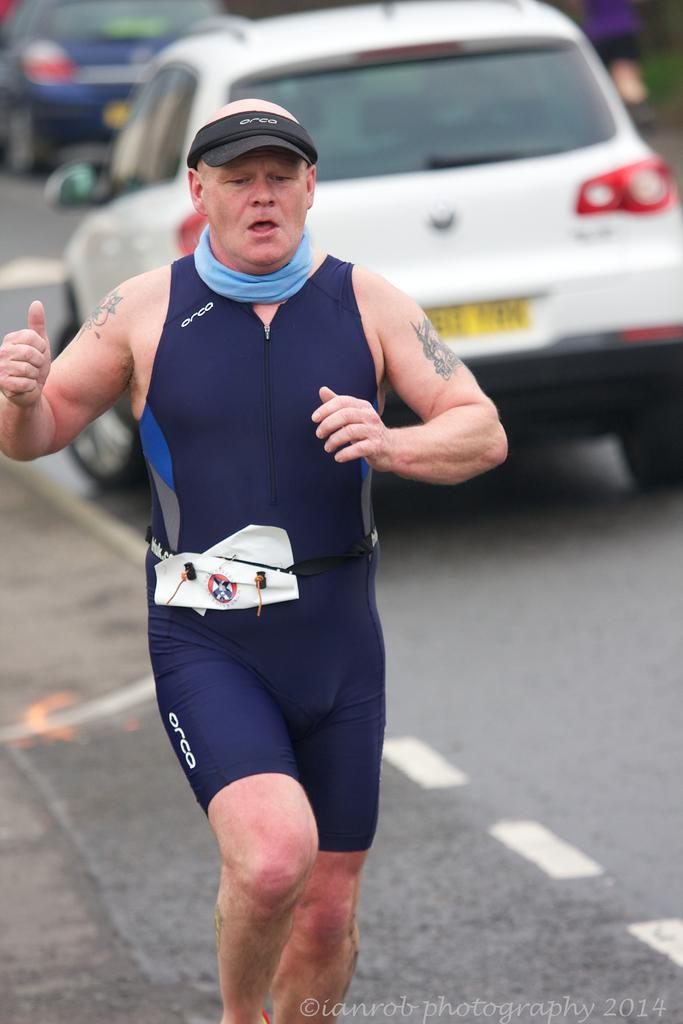What is the main subject of the image? The main subject of the image is a man. What is the man doing in the image? The man is running in the image. Where is the man located in the image? The man is on the left side of the image. What can be seen in the background of the image? There are cars in the background of the image. What size drum is the man holding while running in the image? There is no drum present in the image; the man is simply running. 